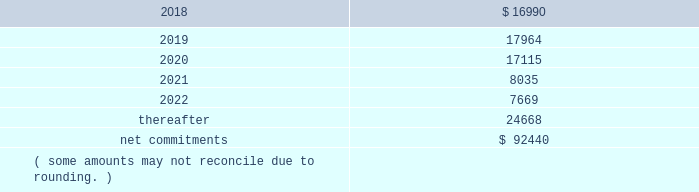On november 18 , 2014 , the company entered into a collateralized reinsurance agreement with kilimanjaro to provide the company with catastrophe reinsurance coverage .
This agreement is a multi-year reinsurance contract which covers specified earthquake events .
The agreement provides up to $ 500000 thousand of reinsurance coverage from earthquakes in the united states , puerto rico and canada .
On december 1 , 2015 the company entered into two collateralized reinsurance agreements with kilimanjaro re to provide the company with catastrophe reinsurance coverage .
These agreements are multi-year reinsurance contracts which cover named storm and earthquake events .
The first agreement provides up to $ 300000 thousand of reinsurance coverage from named storms and earthquakes in the united states , puerto rico and canada .
The second agreement provides up to $ 325000 thousand of reinsurance coverage from named storms and earthquakes in the united states , puerto rico and canada .
On april 13 , 2017 the company entered into six collateralized reinsurance agreements with kilimanjaro to provide the company with annual aggregate catastrophe reinsurance coverage .
The initial three agreements are four year reinsurance contracts which cover named storm and earthquake events .
These agreements provide up to $ 225000 thousand , $ 400000 thousand and $ 325000 thousand , respectively , of annual aggregate reinsurance coverage from named storms and earthquakes in the united states , puerto rico and canada .
The subsequent three agreements are five year reinsurance contracts which cover named storm and earthquake events .
These agreements provide up to $ 50000 thousand , $ 75000 thousand and $ 175000 thousand , respectively , of annual aggregate reinsurance coverage from named storms and earthquakes in the united states , puerto rico and canada .
Recoveries under these collateralized reinsurance agreements with kilimanjaro are primarily dependent on estimated industry level insured losses from covered events , as well as , the geographic location of the events .
The estimated industry level of insured losses is obtained from published estimates by an independent recognized authority on insured property losses .
As of december 31 , 2017 , none of the published insured loss estimates for the 2017 catastrophe events have exceeded the single event retentions under the terms of the agreements that would result in a recovery .
In addition , the aggregation of the to-date published insured loss estimates for the 2017 covered events have not exceeded the aggregated retentions for recovery .
However , if the published estimates for insured losses for the covered 2017 events increase , the aggregate losses may exceed the aggregate event retentions under the agreements , resulting in a recovery .
Kilimanjaro has financed the various property catastrophe reinsurance coverages by issuing catastrophe bonds to unrelated , external investors .
On april 24 , 2014 , kilimanjaro issued $ 450000 thousand of notes ( 201cseries 2014-1 notes 201d ) .
On november 18 , 2014 , kilimanjaro issued $ 500000 thousand of notes ( 201cseries 2014-2 notes 201d ) .
On december 1 , 2015 , kilimanjaro issued $ 625000 thousand of notes ( 201cseries 2015-1 notes ) .
On april 13 , 2017 , kilimanjaro issued $ 950000 thousand of notes ( 201cseries 2017-1 notes ) and $ 300000 thousand of notes ( 201cseries 2017-2 notes ) .
The proceeds from the issuance of the notes listed above are held in reinsurance trust throughout the duration of the applicable reinsurance agreements and invested solely in us government money market funds with a rating of at least 201caaam 201d by standard & poor 2019s .
Operating lease agreements the future minimum rental commitments , exclusive of cost escalation clauses , at december 31 , 2017 , for all of the company 2019s operating leases with remaining non-cancelable terms in excess of one year are as follows : ( dollars in thousands ) .

What is the percent of the company 2019s operating leases that would be due after 2022 as part of the net commitments? 
Computations: (24668 / 92440)
Answer: 0.26685. 